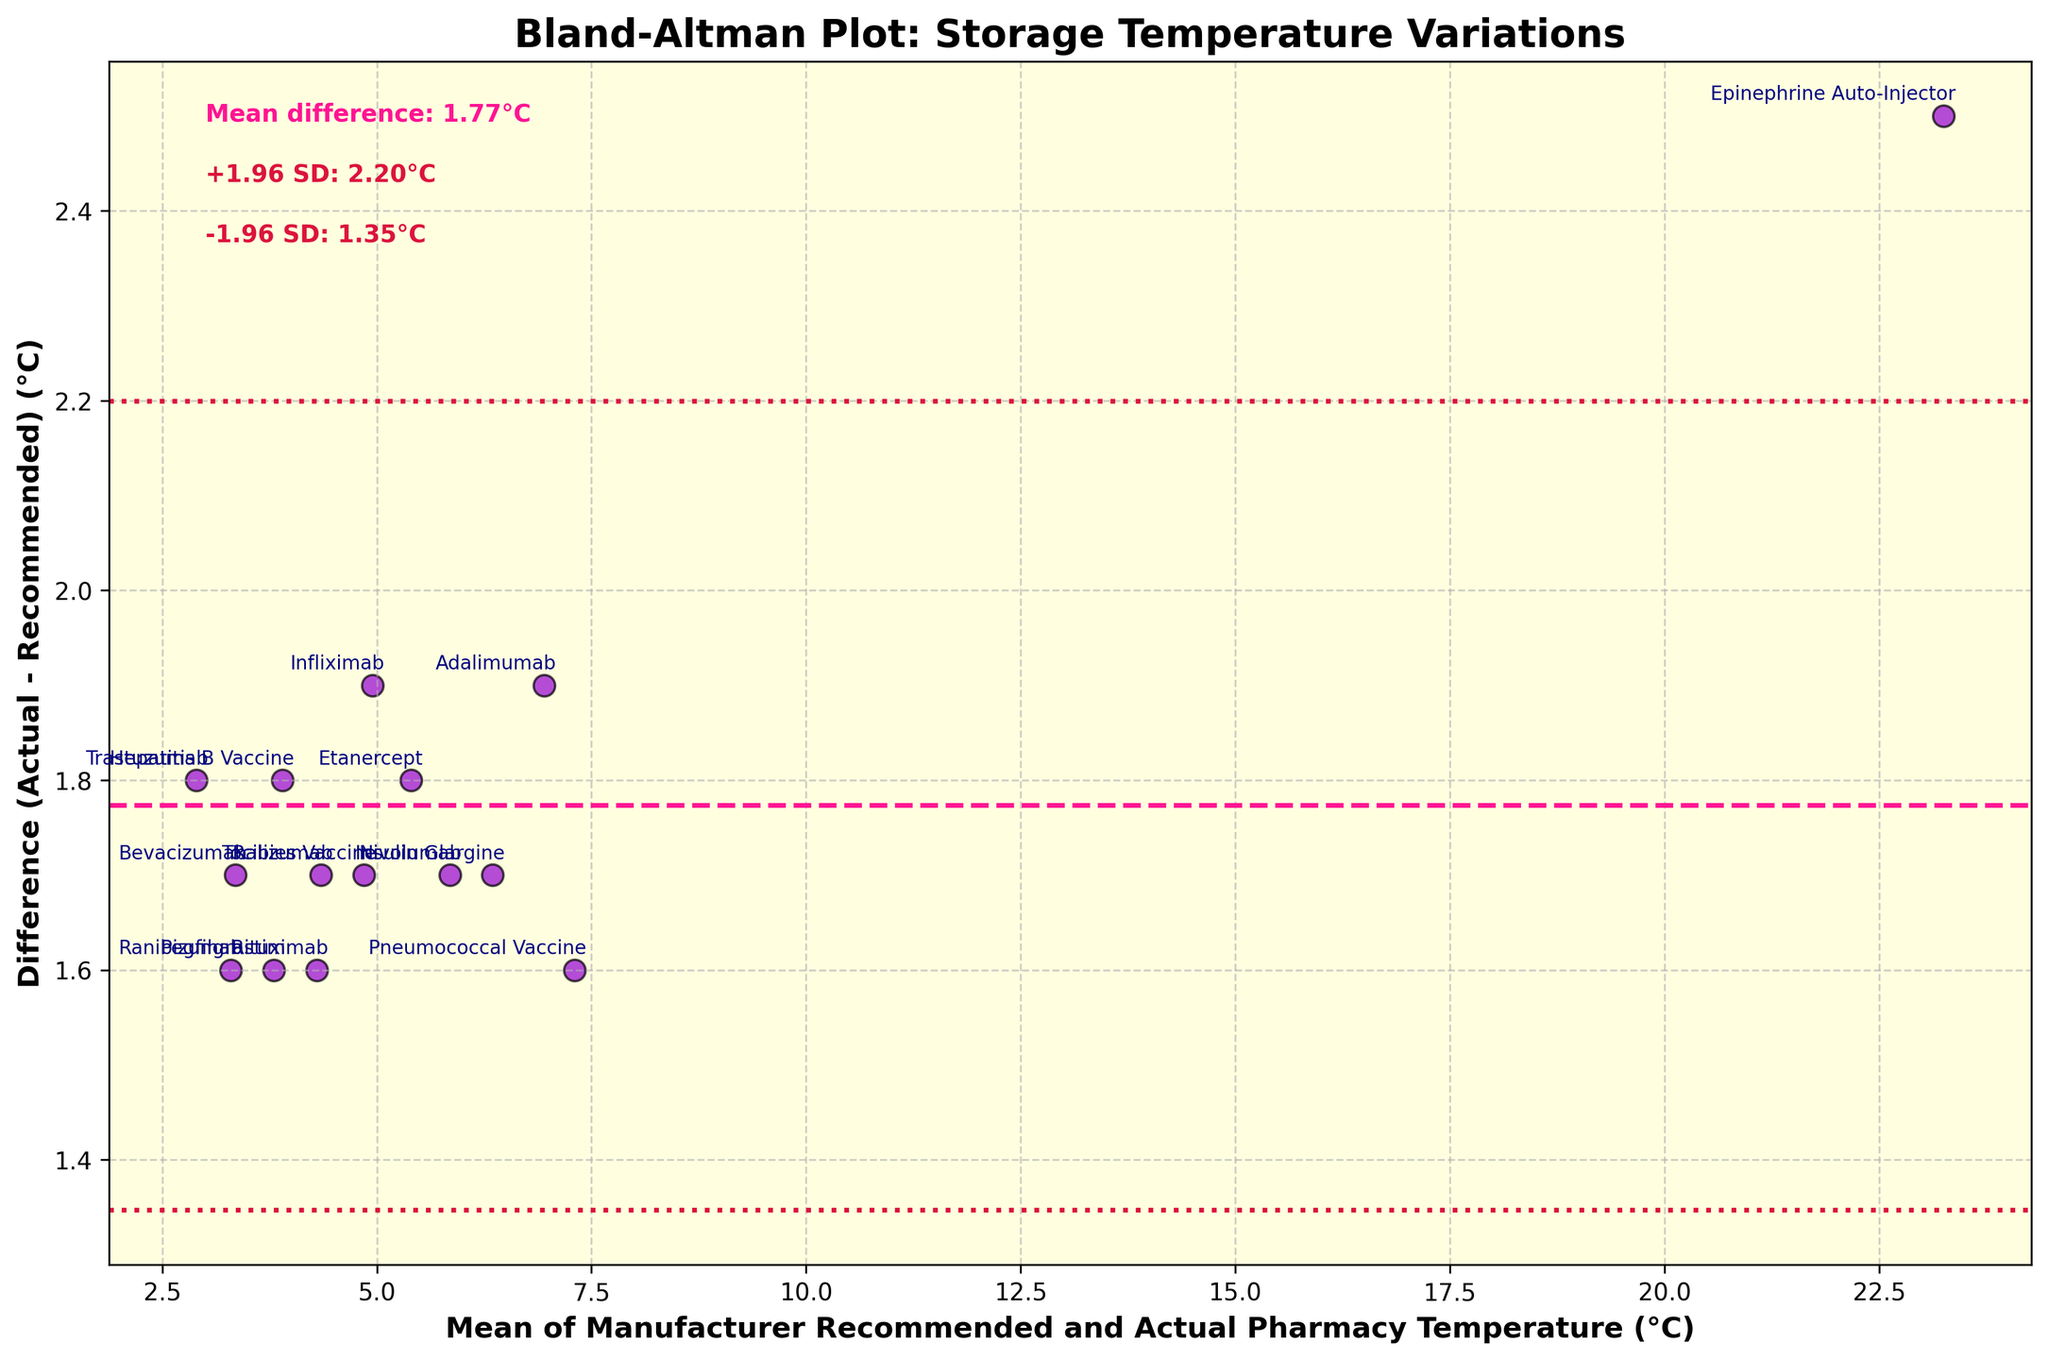What's the title of the plot? The title of the plot is located at the top of the figure and reads "Bland-Altman Plot: Storage Temperature Variations".
Answer: Bland-Altman Plot: Storage Temperature Variations How many data points are there on the plot? By counting the number of scatter points on the plot, we can see there are 15 data points, each representing a different medication.
Answer: 15 What are the colors used for the scatter points and the reference lines? The scatter points are dark violet with black edges. The mean difference line is deep pink, and the lines at +1.96 and -1.96 standard deviations are crimson.
Answer: Dark violet (scatter points), deep pink (mean difference), crimson (±1.96 SD) What is the mean difference in temperature indicated on the plot? The plot shows a dashed line labeled as the "Mean difference: 1.72°C".
Answer: 1.72°C What do the lines at +1.96 SD and -1.96 SD correspond to in terms of temperature difference? The plot annotates these lines with values: "+1.96 SD: 2.97°C" and "-1.96 SD: 0.48°C".
Answer: +2.97°C and -0.48°C Which medication has the highest difference between the actual and recommended temperatures? By checking labels annotated near the highest point above the mean difference line, the medication "Epinephrine Auto-Injector" has the highest difference.
Answer: Epinephrine Auto-Injector Which medication has the lowest difference between the actual and recommended temperatures? By checking labels annotated nearest to the intersection of the mean difference line, the medication "Hepatitis B Vaccine" has the lowest difference.
Answer: Hepatitis B Vaccine Which medications have a mean temperature value above 10°C? The plot shows mean temperature values on the x-axis. None of the scatter points reach 10°C and above, so no medications have a mean value above 10°C.
Answer: None What is the mean temperature range displayed on the x-axis? The x-axis represents mean temperature values, ranging from approximately 2°C to 8°C.
Answer: 2°C to 8°C What is the relationship between the mean temperature of insulin glargine and its temperature difference? By locating insulin glargine on the plot, we observe its mean temperature is around 6.35°C, with a difference above 1.5°C but below 3°C.
Answer: Mean ~6.35°C, Difference ~1.7°C 